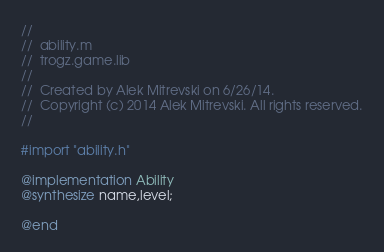<code> <loc_0><loc_0><loc_500><loc_500><_ObjectiveC_>//
//  ability.m
//  trogz.game.lib
//
//  Created by Alek Mitrevski on 6/26/14.
//  Copyright (c) 2014 Alek Mitrevski. All rights reserved.
//

#import "ability.h"

@implementation Ability
@synthesize name,level;

@end
</code> 